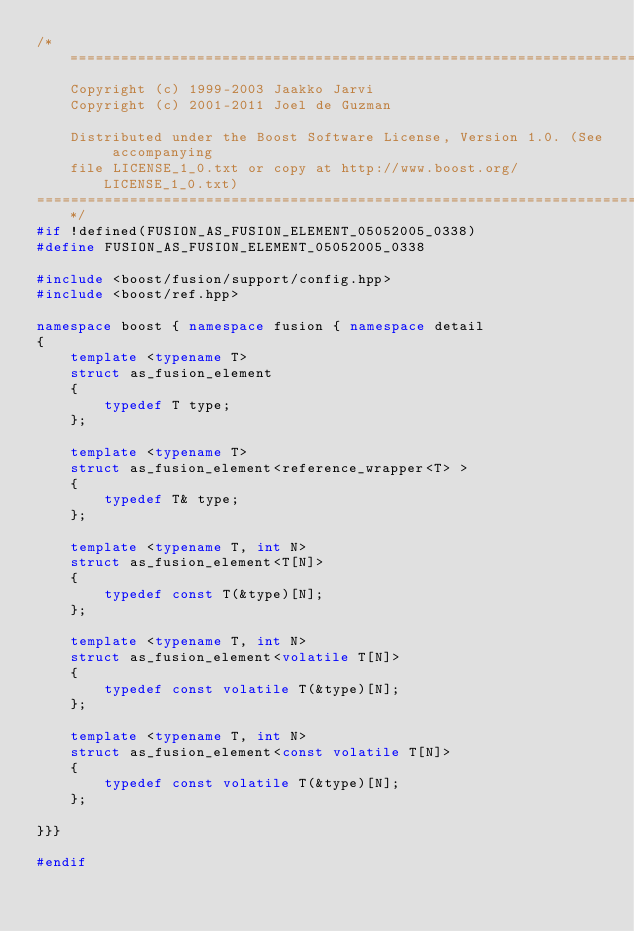<code> <loc_0><loc_0><loc_500><loc_500><_C++_>/*=============================================================================
    Copyright (c) 1999-2003 Jaakko Jarvi
    Copyright (c) 2001-2011 Joel de Guzman

    Distributed under the Boost Software License, Version 1.0. (See accompanying 
    file LICENSE_1_0.txt or copy at http://www.boost.org/LICENSE_1_0.txt)
==============================================================================*/
#if !defined(FUSION_AS_FUSION_ELEMENT_05052005_0338)
#define FUSION_AS_FUSION_ELEMENT_05052005_0338

#include <boost/fusion/support/config.hpp>
#include <boost/ref.hpp>

namespace boost { namespace fusion { namespace detail
{
    template <typename T>
    struct as_fusion_element
    {
        typedef T type;
    };

    template <typename T>
    struct as_fusion_element<reference_wrapper<T> >
    {
        typedef T& type;
    };

    template <typename T, int N>
    struct as_fusion_element<T[N]>
    {
        typedef const T(&type)[N];
    };

    template <typename T, int N>
    struct as_fusion_element<volatile T[N]>
    {
        typedef const volatile T(&type)[N];
    };

    template <typename T, int N>
    struct as_fusion_element<const volatile T[N]>
    {
        typedef const volatile T(&type)[N];
    };

}}}

#endif
</code> 